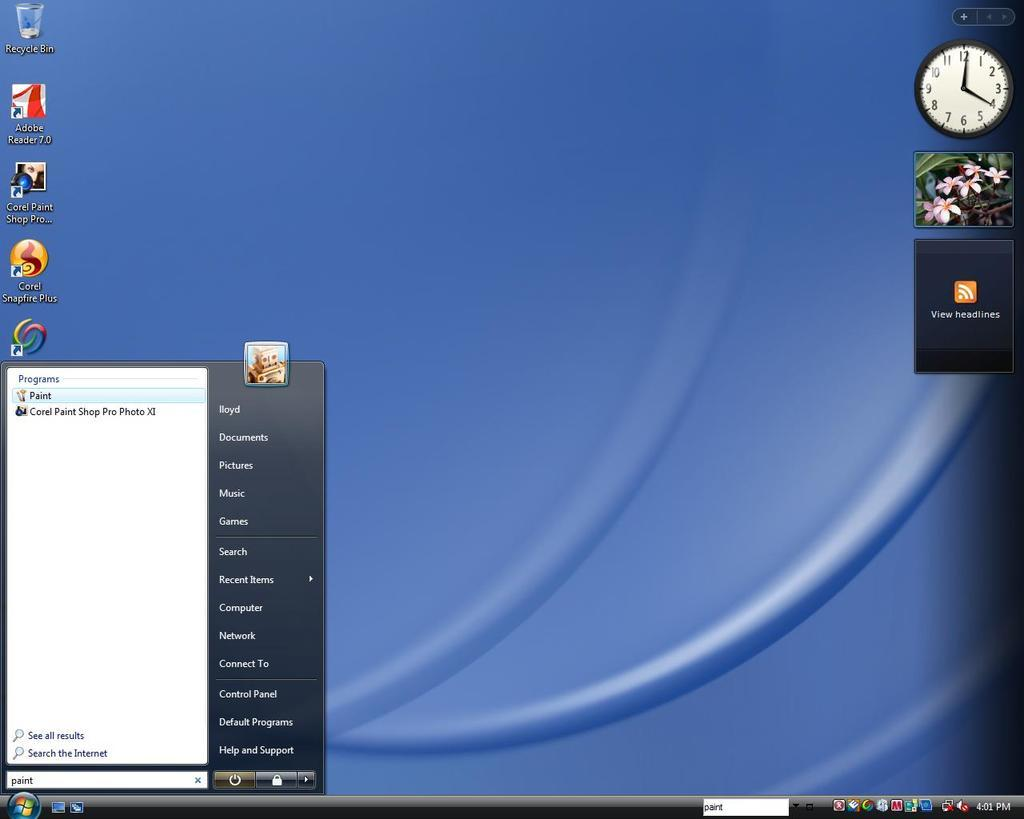<image>
Summarize the visual content of the image. A computer monitor screen has the word bin on it. 